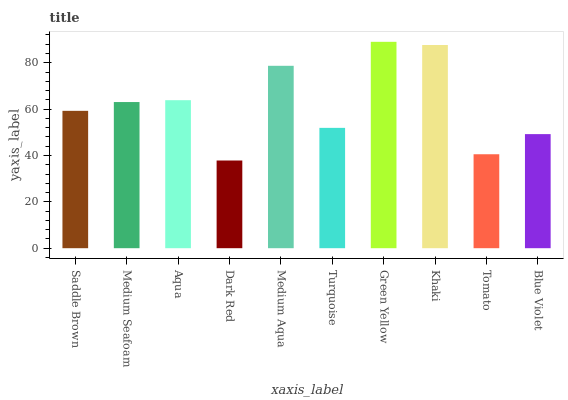Is Dark Red the minimum?
Answer yes or no. Yes. Is Green Yellow the maximum?
Answer yes or no. Yes. Is Medium Seafoam the minimum?
Answer yes or no. No. Is Medium Seafoam the maximum?
Answer yes or no. No. Is Medium Seafoam greater than Saddle Brown?
Answer yes or no. Yes. Is Saddle Brown less than Medium Seafoam?
Answer yes or no. Yes. Is Saddle Brown greater than Medium Seafoam?
Answer yes or no. No. Is Medium Seafoam less than Saddle Brown?
Answer yes or no. No. Is Medium Seafoam the high median?
Answer yes or no. Yes. Is Saddle Brown the low median?
Answer yes or no. Yes. Is Medium Aqua the high median?
Answer yes or no. No. Is Tomato the low median?
Answer yes or no. No. 